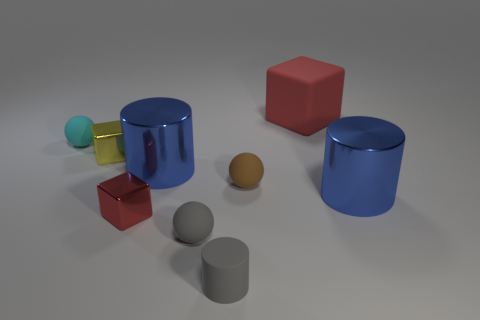There is a large metallic cylinder on the left side of the blue metal object on the right side of the small gray ball; what color is it?
Ensure brevity in your answer.  Blue. How many things are either small gray matte things or tiny rubber spheres in front of the cyan matte ball?
Your answer should be very brief. 3. There is a small sphere behind the yellow shiny object; what color is it?
Provide a short and direct response. Cyan. There is a cyan object; what shape is it?
Your answer should be compact. Sphere. What is the material of the block that is right of the large blue shiny thing that is left of the big red cube?
Your response must be concise. Rubber. How many other things are the same material as the tiny yellow object?
Your answer should be compact. 3. There is a red object that is the same size as the gray ball; what material is it?
Your answer should be compact. Metal. Are there more red rubber blocks behind the gray cylinder than tiny yellow things that are left of the tiny cyan rubber thing?
Give a very brief answer. Yes. Are there any gray things that have the same shape as the cyan thing?
Give a very brief answer. Yes. What is the shape of the cyan rubber thing that is the same size as the brown object?
Provide a succinct answer. Sphere. 